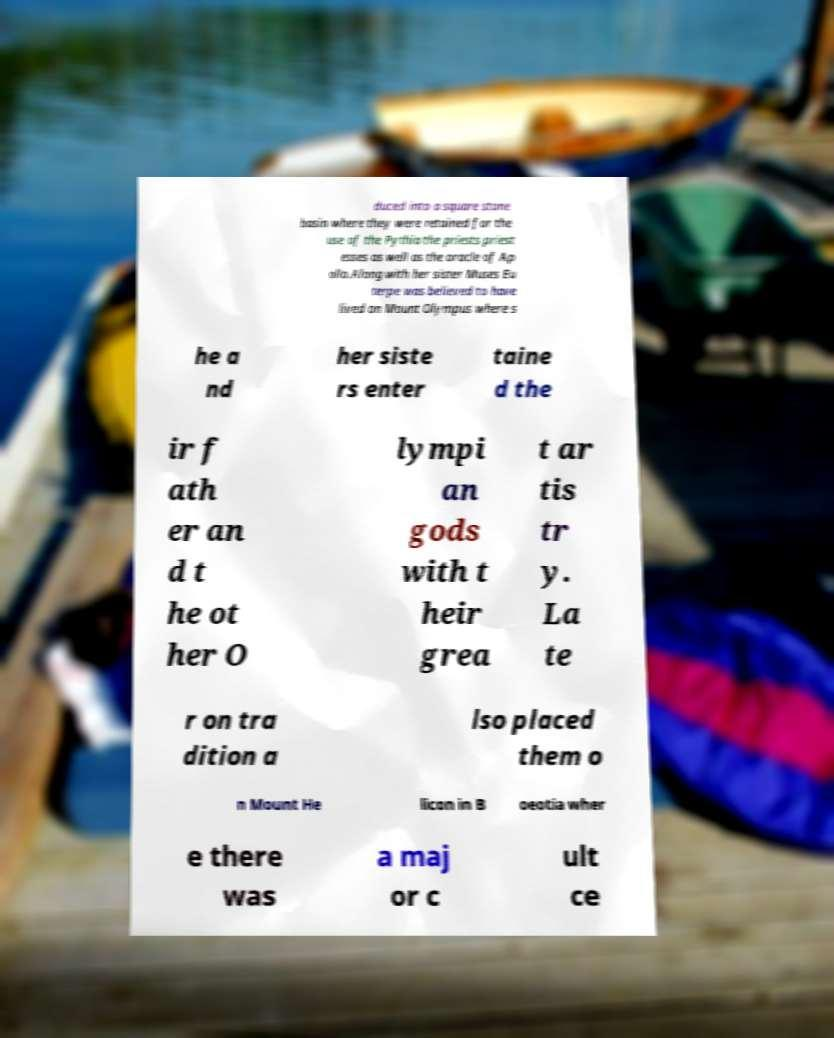What messages or text are displayed in this image? I need them in a readable, typed format. duced into a square stone basin where they were retained for the use of the Pythia the priests priest esses as well as the oracle of Ap ollo.Along with her sister Muses Eu terpe was believed to have lived on Mount Olympus where s he a nd her siste rs enter taine d the ir f ath er an d t he ot her O lympi an gods with t heir grea t ar tis tr y. La te r on tra dition a lso placed them o n Mount He licon in B oeotia wher e there was a maj or c ult ce 